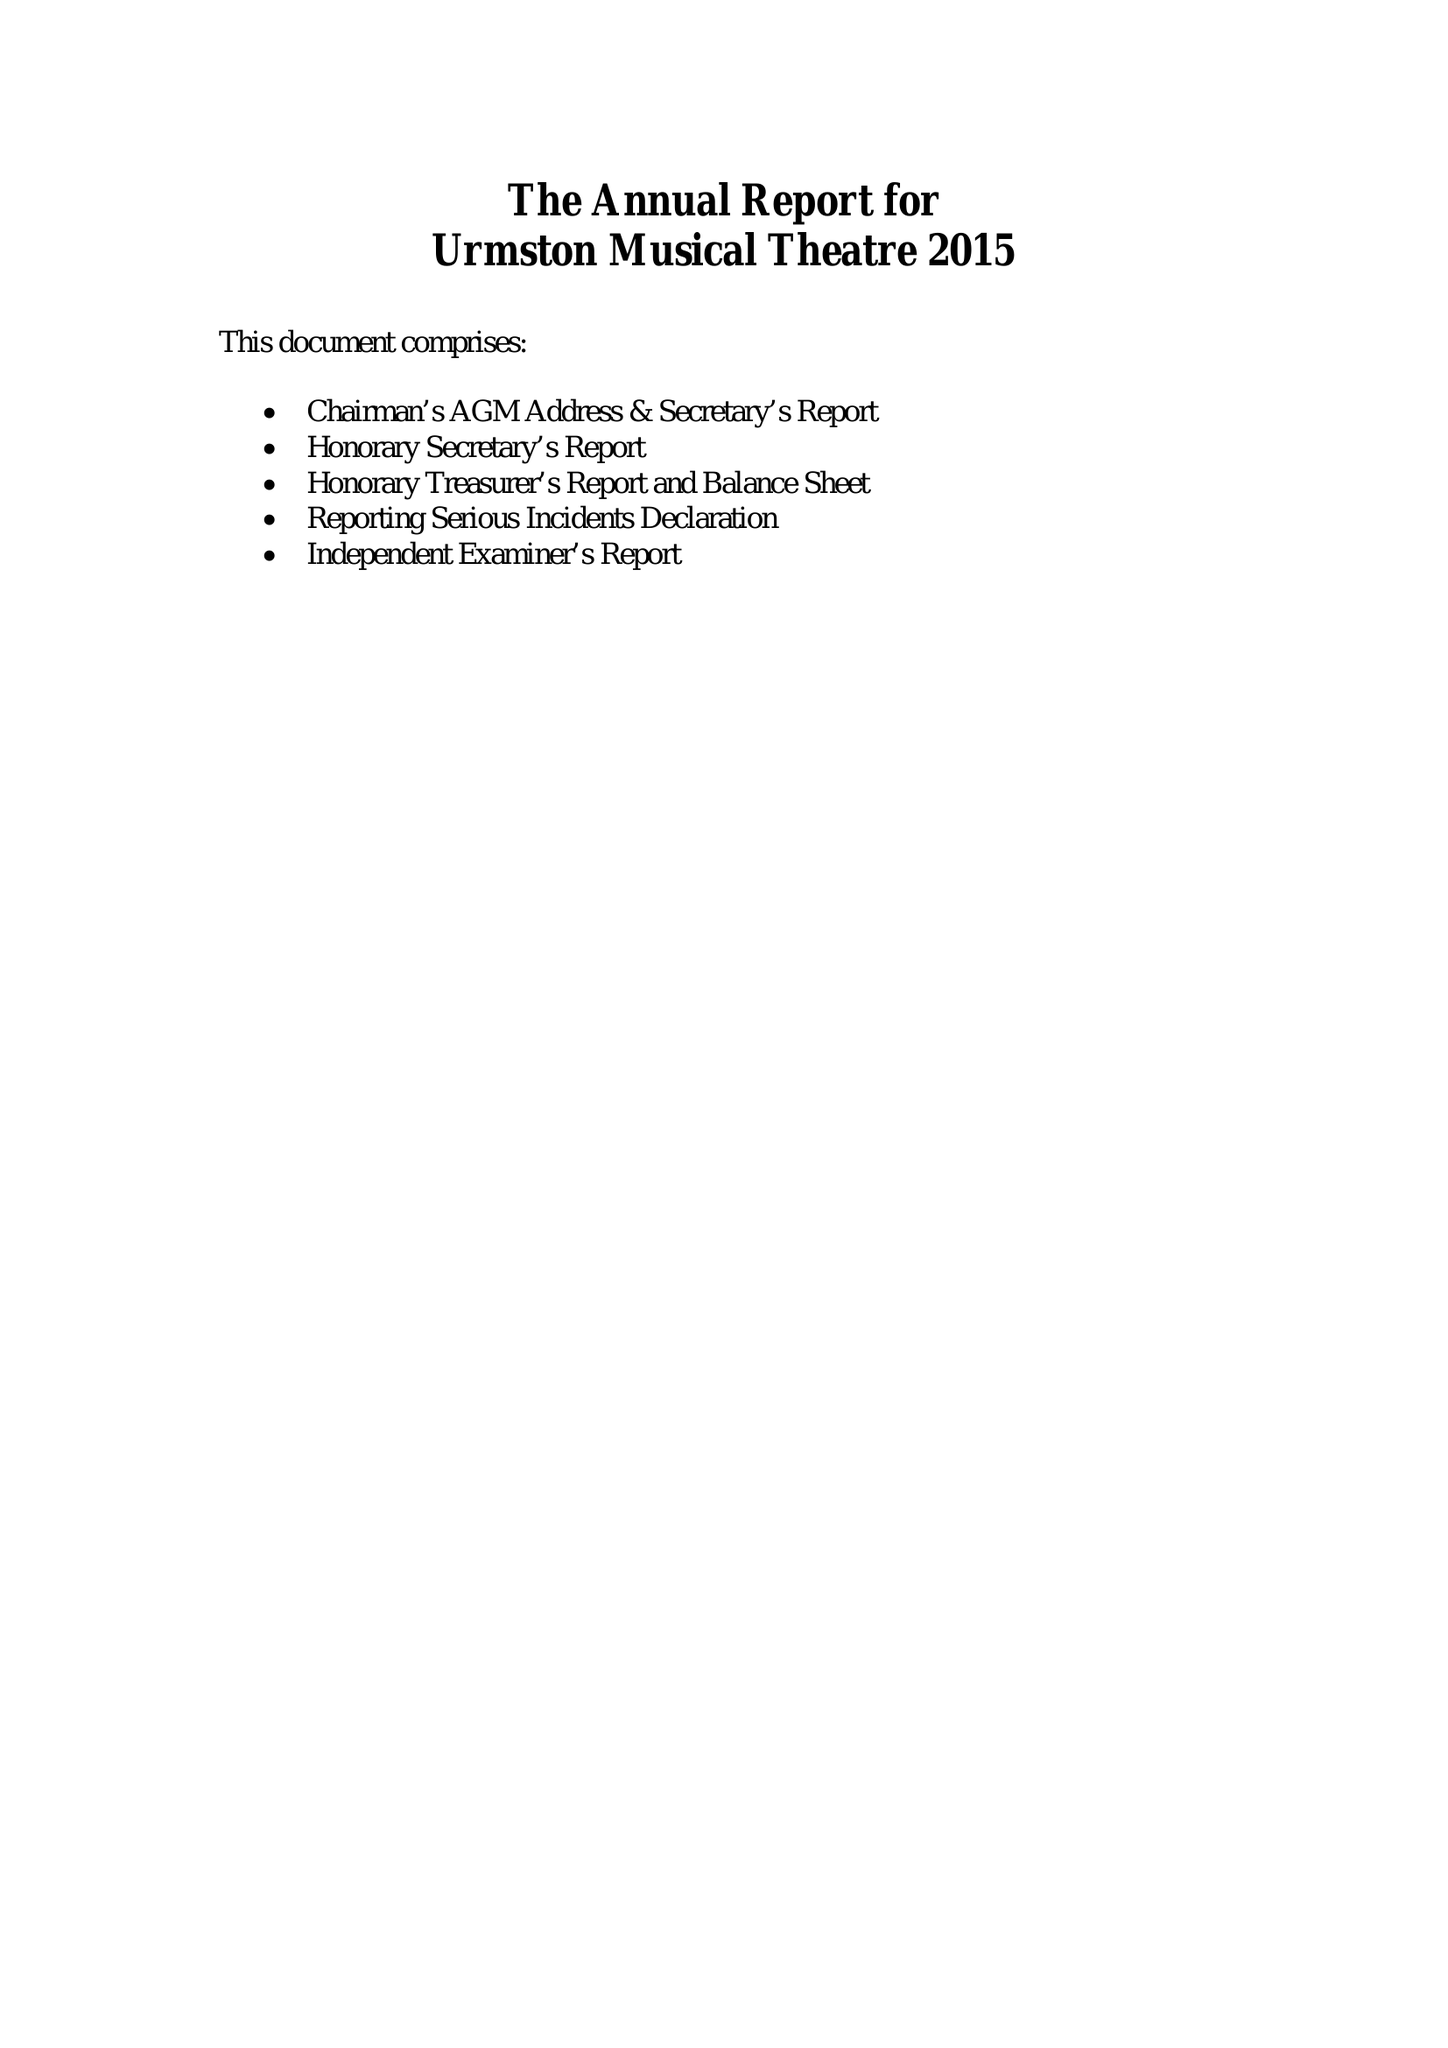What is the value for the charity_number?
Answer the question using a single word or phrase. 1119510 